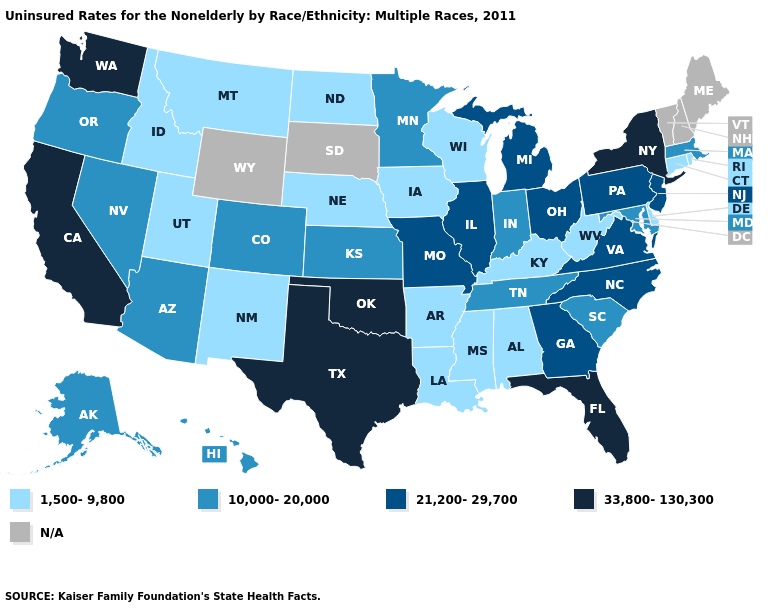Does Maryland have the lowest value in the South?
Concise answer only. No. Name the states that have a value in the range 21,200-29,700?
Short answer required. Georgia, Illinois, Michigan, Missouri, New Jersey, North Carolina, Ohio, Pennsylvania, Virginia. Which states have the lowest value in the West?
Short answer required. Idaho, Montana, New Mexico, Utah. Which states have the highest value in the USA?
Be succinct. California, Florida, New York, Oklahoma, Texas, Washington. Does the first symbol in the legend represent the smallest category?
Give a very brief answer. Yes. Name the states that have a value in the range N/A?
Concise answer only. Maine, New Hampshire, South Dakota, Vermont, Wyoming. Name the states that have a value in the range 33,800-130,300?
Be succinct. California, Florida, New York, Oklahoma, Texas, Washington. Which states have the highest value in the USA?
Short answer required. California, Florida, New York, Oklahoma, Texas, Washington. Is the legend a continuous bar?
Concise answer only. No. Name the states that have a value in the range 1,500-9,800?
Quick response, please. Alabama, Arkansas, Connecticut, Delaware, Idaho, Iowa, Kentucky, Louisiana, Mississippi, Montana, Nebraska, New Mexico, North Dakota, Rhode Island, Utah, West Virginia, Wisconsin. What is the lowest value in states that border North Carolina?
Give a very brief answer. 10,000-20,000. What is the value of New Mexico?
Quick response, please. 1,500-9,800. Does Rhode Island have the lowest value in the Northeast?
Concise answer only. Yes. Which states hav the highest value in the MidWest?
Answer briefly. Illinois, Michigan, Missouri, Ohio. 